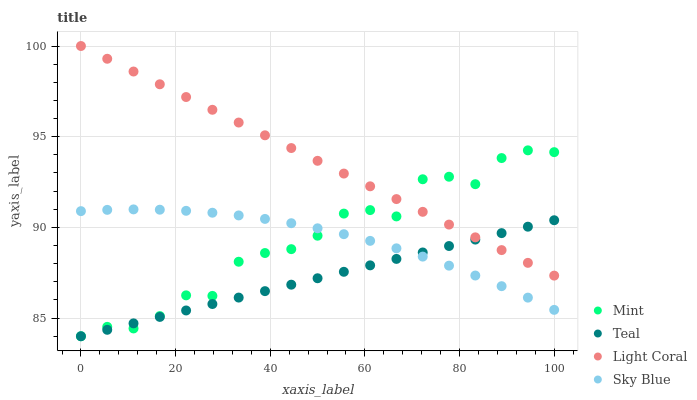Does Teal have the minimum area under the curve?
Answer yes or no. Yes. Does Light Coral have the maximum area under the curve?
Answer yes or no. Yes. Does Sky Blue have the minimum area under the curve?
Answer yes or no. No. Does Sky Blue have the maximum area under the curve?
Answer yes or no. No. Is Light Coral the smoothest?
Answer yes or no. Yes. Is Mint the roughest?
Answer yes or no. Yes. Is Sky Blue the smoothest?
Answer yes or no. No. Is Sky Blue the roughest?
Answer yes or no. No. Does Mint have the lowest value?
Answer yes or no. Yes. Does Sky Blue have the lowest value?
Answer yes or no. No. Does Light Coral have the highest value?
Answer yes or no. Yes. Does Sky Blue have the highest value?
Answer yes or no. No. Is Sky Blue less than Light Coral?
Answer yes or no. Yes. Is Light Coral greater than Sky Blue?
Answer yes or no. Yes. Does Mint intersect Sky Blue?
Answer yes or no. Yes. Is Mint less than Sky Blue?
Answer yes or no. No. Is Mint greater than Sky Blue?
Answer yes or no. No. Does Sky Blue intersect Light Coral?
Answer yes or no. No. 